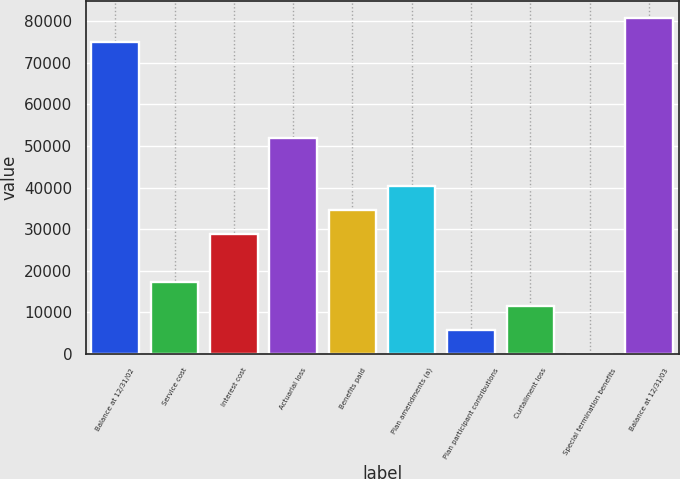Convert chart to OTSL. <chart><loc_0><loc_0><loc_500><loc_500><bar_chart><fcel>Balance at 12/31/02<fcel>Service cost<fcel>Interest cost<fcel>Actuarial loss<fcel>Benefits paid<fcel>Plan amendments (a)<fcel>Plan participant contributions<fcel>Curtailment loss<fcel>Special termination benefits<fcel>Balance at 12/31/03<nl><fcel>75099.9<fcel>17386.9<fcel>28929.5<fcel>52014.7<fcel>34700.8<fcel>40472.1<fcel>5844.3<fcel>11615.6<fcel>73<fcel>80871.2<nl></chart> 